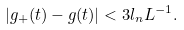Convert formula to latex. <formula><loc_0><loc_0><loc_500><loc_500>| g _ { + } ( t ) - g ( t ) | < 3 l _ { n } L ^ { - 1 } .</formula> 